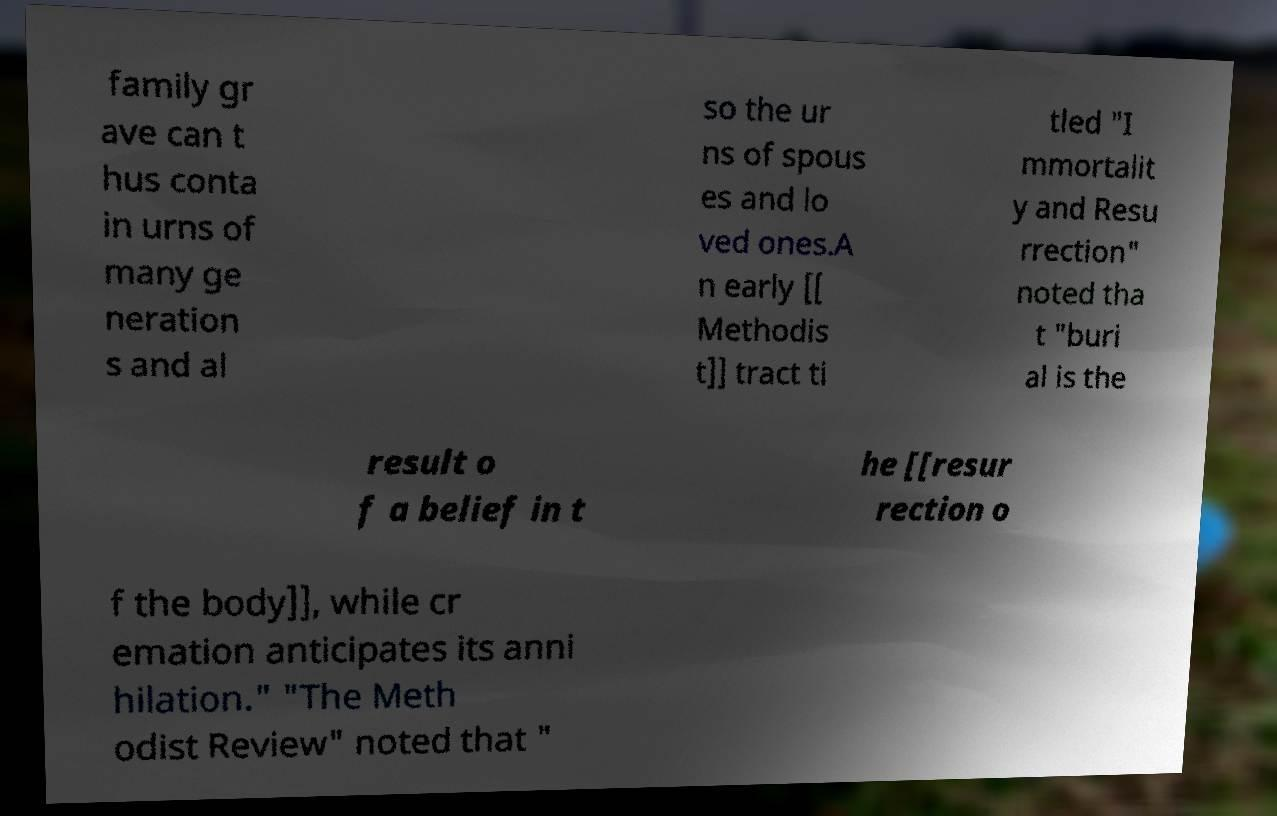What messages or text are displayed in this image? I need them in a readable, typed format. family gr ave can t hus conta in urns of many ge neration s and al so the ur ns of spous es and lo ved ones.A n early [[ Methodis t]] tract ti tled "I mmortalit y and Resu rrection" noted tha t "buri al is the result o f a belief in t he [[resur rection o f the body]], while cr emation anticipates its anni hilation." "The Meth odist Review" noted that " 